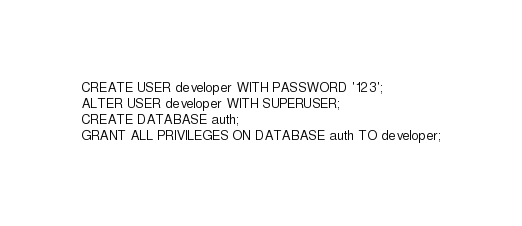<code> <loc_0><loc_0><loc_500><loc_500><_SQL_>CREATE USER developer WITH PASSWORD '123';
ALTER USER developer WITH SUPERUSER;
CREATE DATABASE auth;
GRANT ALL PRIVILEGES ON DATABASE auth TO developer;
</code> 